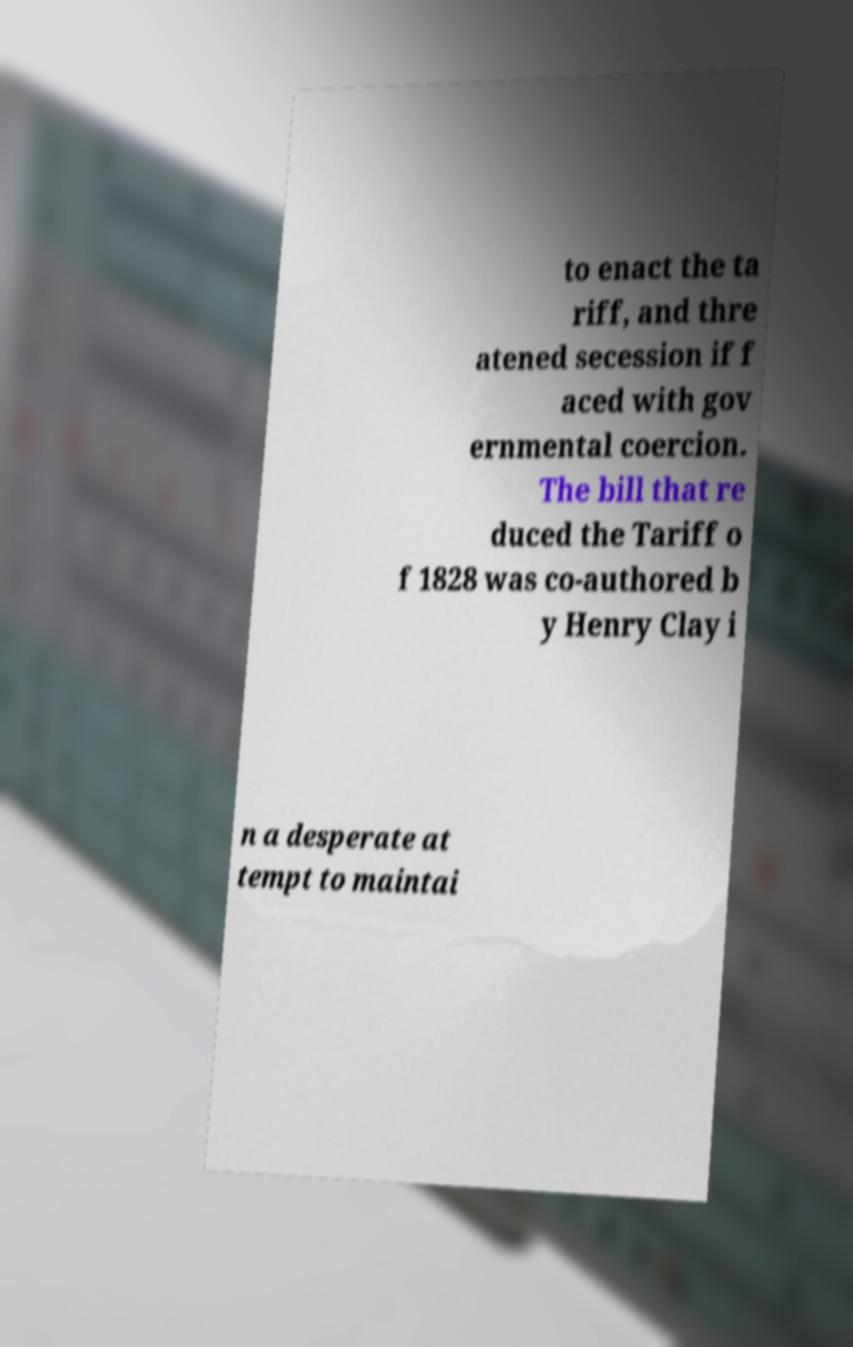Can you accurately transcribe the text from the provided image for me? to enact the ta riff, and thre atened secession if f aced with gov ernmental coercion. The bill that re duced the Tariff o f 1828 was co-authored b y Henry Clay i n a desperate at tempt to maintai 